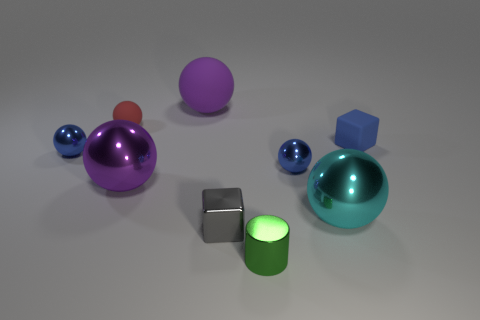Is the number of cyan balls that are left of the tiny gray object greater than the number of red metallic cylinders? no 